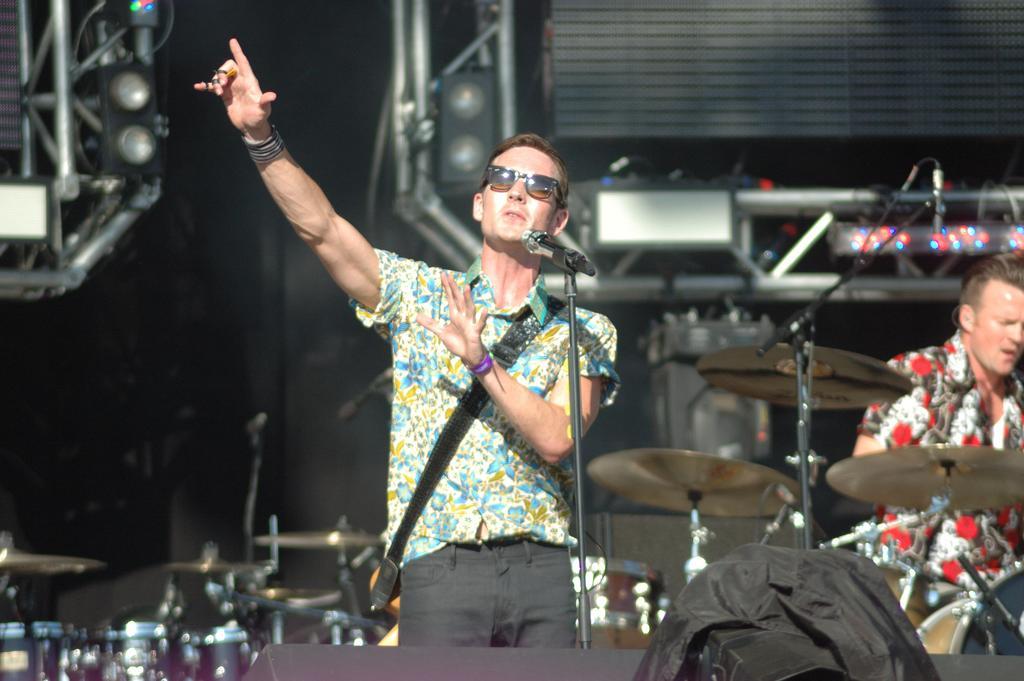How would you summarize this image in a sentence or two? In the image it is a a concert there are two men first man standing and singing a song, the second man is playing the drums,there is a bag in front of him behind the first man there are other musical instruments and it is a massive set with a lot of lights and and other instruments. 